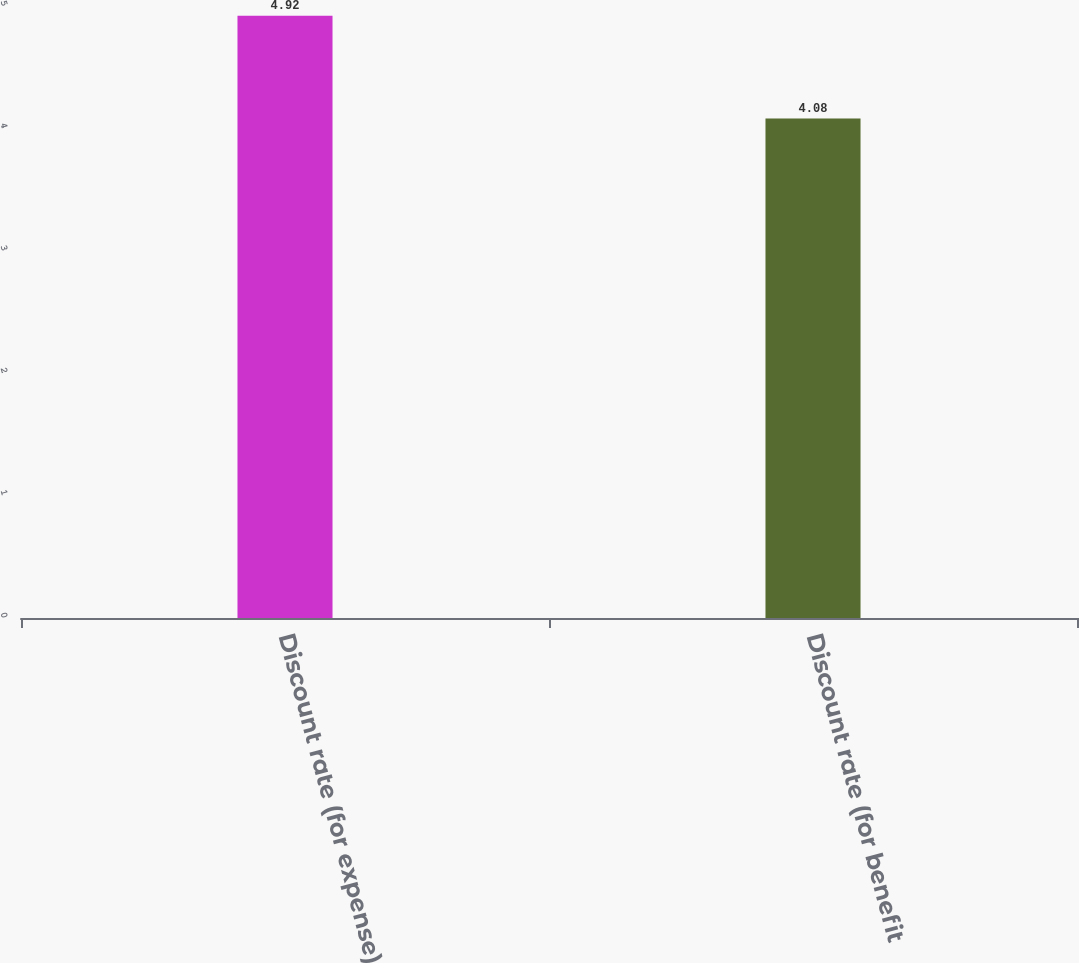<chart> <loc_0><loc_0><loc_500><loc_500><bar_chart><fcel>Discount rate (for expense)<fcel>Discount rate (for benefit<nl><fcel>4.92<fcel>4.08<nl></chart> 